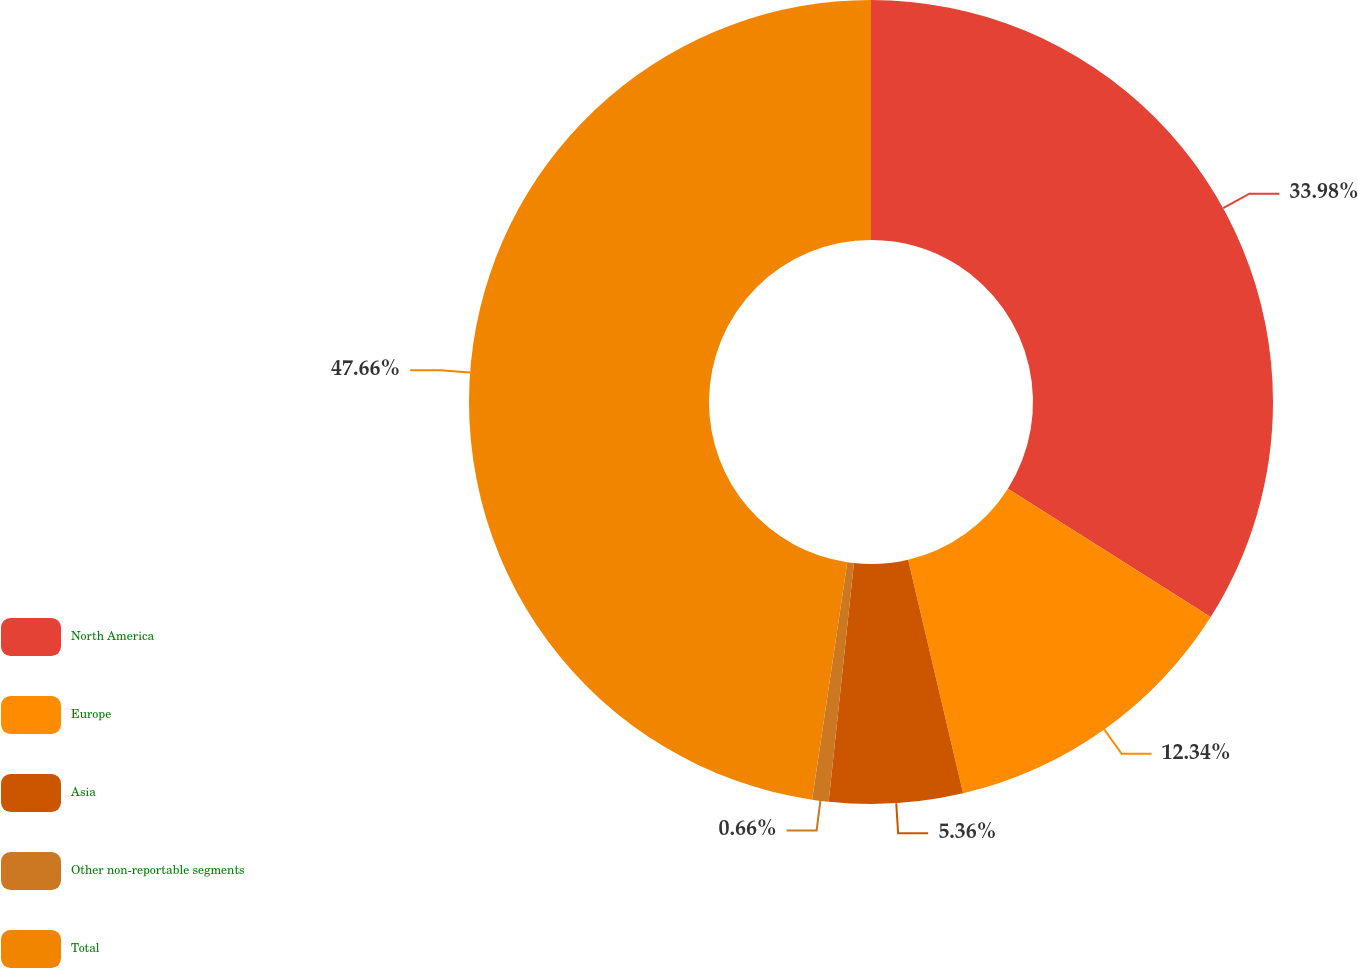Convert chart to OTSL. <chart><loc_0><loc_0><loc_500><loc_500><pie_chart><fcel>North America<fcel>Europe<fcel>Asia<fcel>Other non-reportable segments<fcel>Total<nl><fcel>33.98%<fcel>12.34%<fcel>5.36%<fcel>0.66%<fcel>47.66%<nl></chart> 